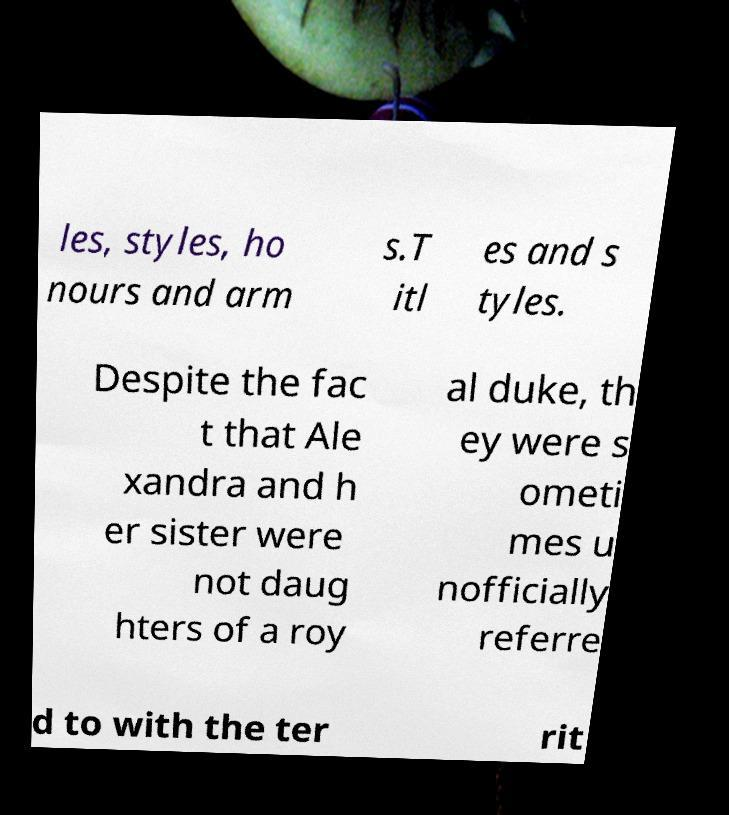Could you assist in decoding the text presented in this image and type it out clearly? les, styles, ho nours and arm s.T itl es and s tyles. Despite the fac t that Ale xandra and h er sister were not daug hters of a roy al duke, th ey were s ometi mes u nofficially referre d to with the ter rit 